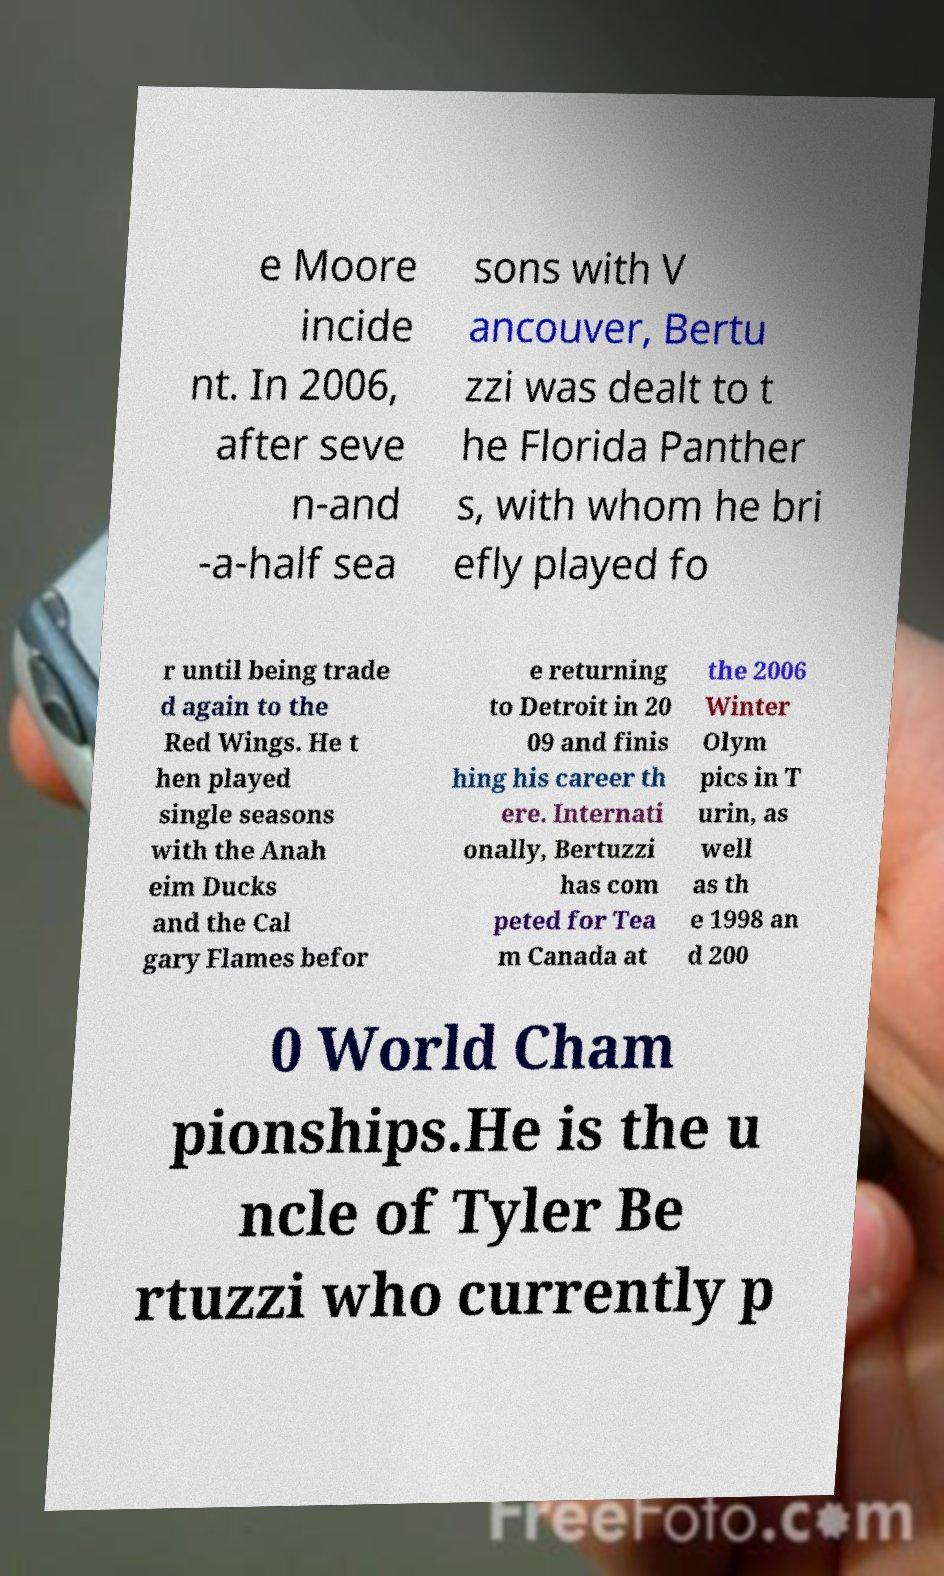Please read and relay the text visible in this image. What does it say? e Moore incide nt. In 2006, after seve n-and -a-half sea sons with V ancouver, Bertu zzi was dealt to t he Florida Panther s, with whom he bri efly played fo r until being trade d again to the Red Wings. He t hen played single seasons with the Anah eim Ducks and the Cal gary Flames befor e returning to Detroit in 20 09 and finis hing his career th ere. Internati onally, Bertuzzi has com peted for Tea m Canada at the 2006 Winter Olym pics in T urin, as well as th e 1998 an d 200 0 World Cham pionships.He is the u ncle of Tyler Be rtuzzi who currently p 